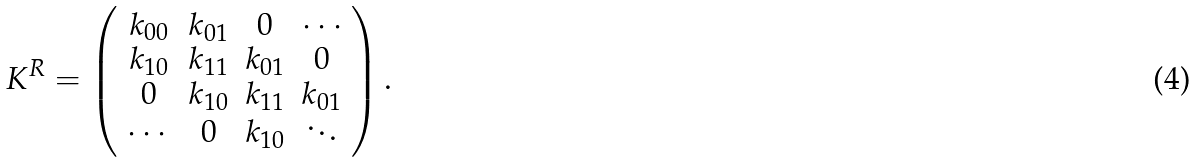Convert formula to latex. <formula><loc_0><loc_0><loc_500><loc_500>K ^ { R } = \left ( \begin{array} { c c c c } k _ { 0 0 } & k _ { 0 1 } & 0 & \cdots \\ k _ { 1 0 } & k _ { 1 1 } & k _ { 0 1 } & 0 \\ 0 & k _ { 1 0 } & k _ { 1 1 } & k _ { 0 1 } \\ \cdots & 0 & k _ { 1 0 } & \ddots \end{array} \right ) .</formula> 